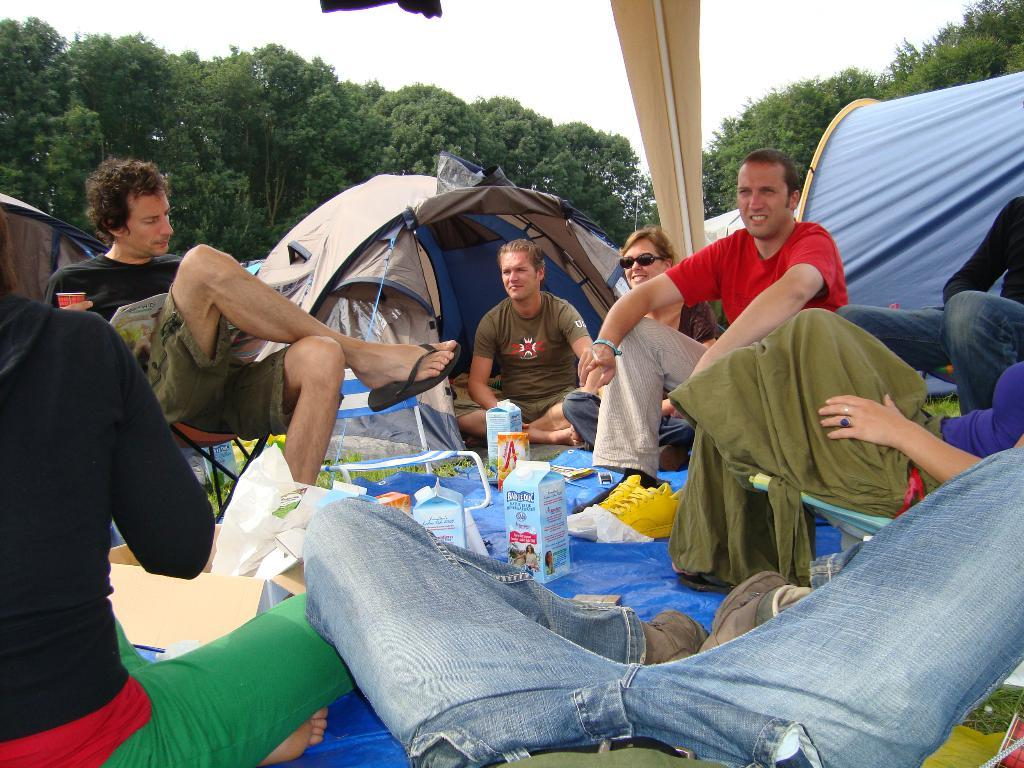What are the persons in the image doing? The persons in the image are sitting on chairs and on the floor. What objects are present in the image that might be used for packaging or storage? Cardboard cartons and polythene covers are visible in the image. What type of temporary shelter is present in the image? Tents are present in the image. What type of natural vegetation is visible in the image? Trees are visible in the image. What part of the natural environment is visible in the image? The sky is visible in the image. What type of pain is the person experiencing in the image? There is no indication in the image that any person is experiencing pain. What type of pie is being served in the image? There is no pie present in the image. 